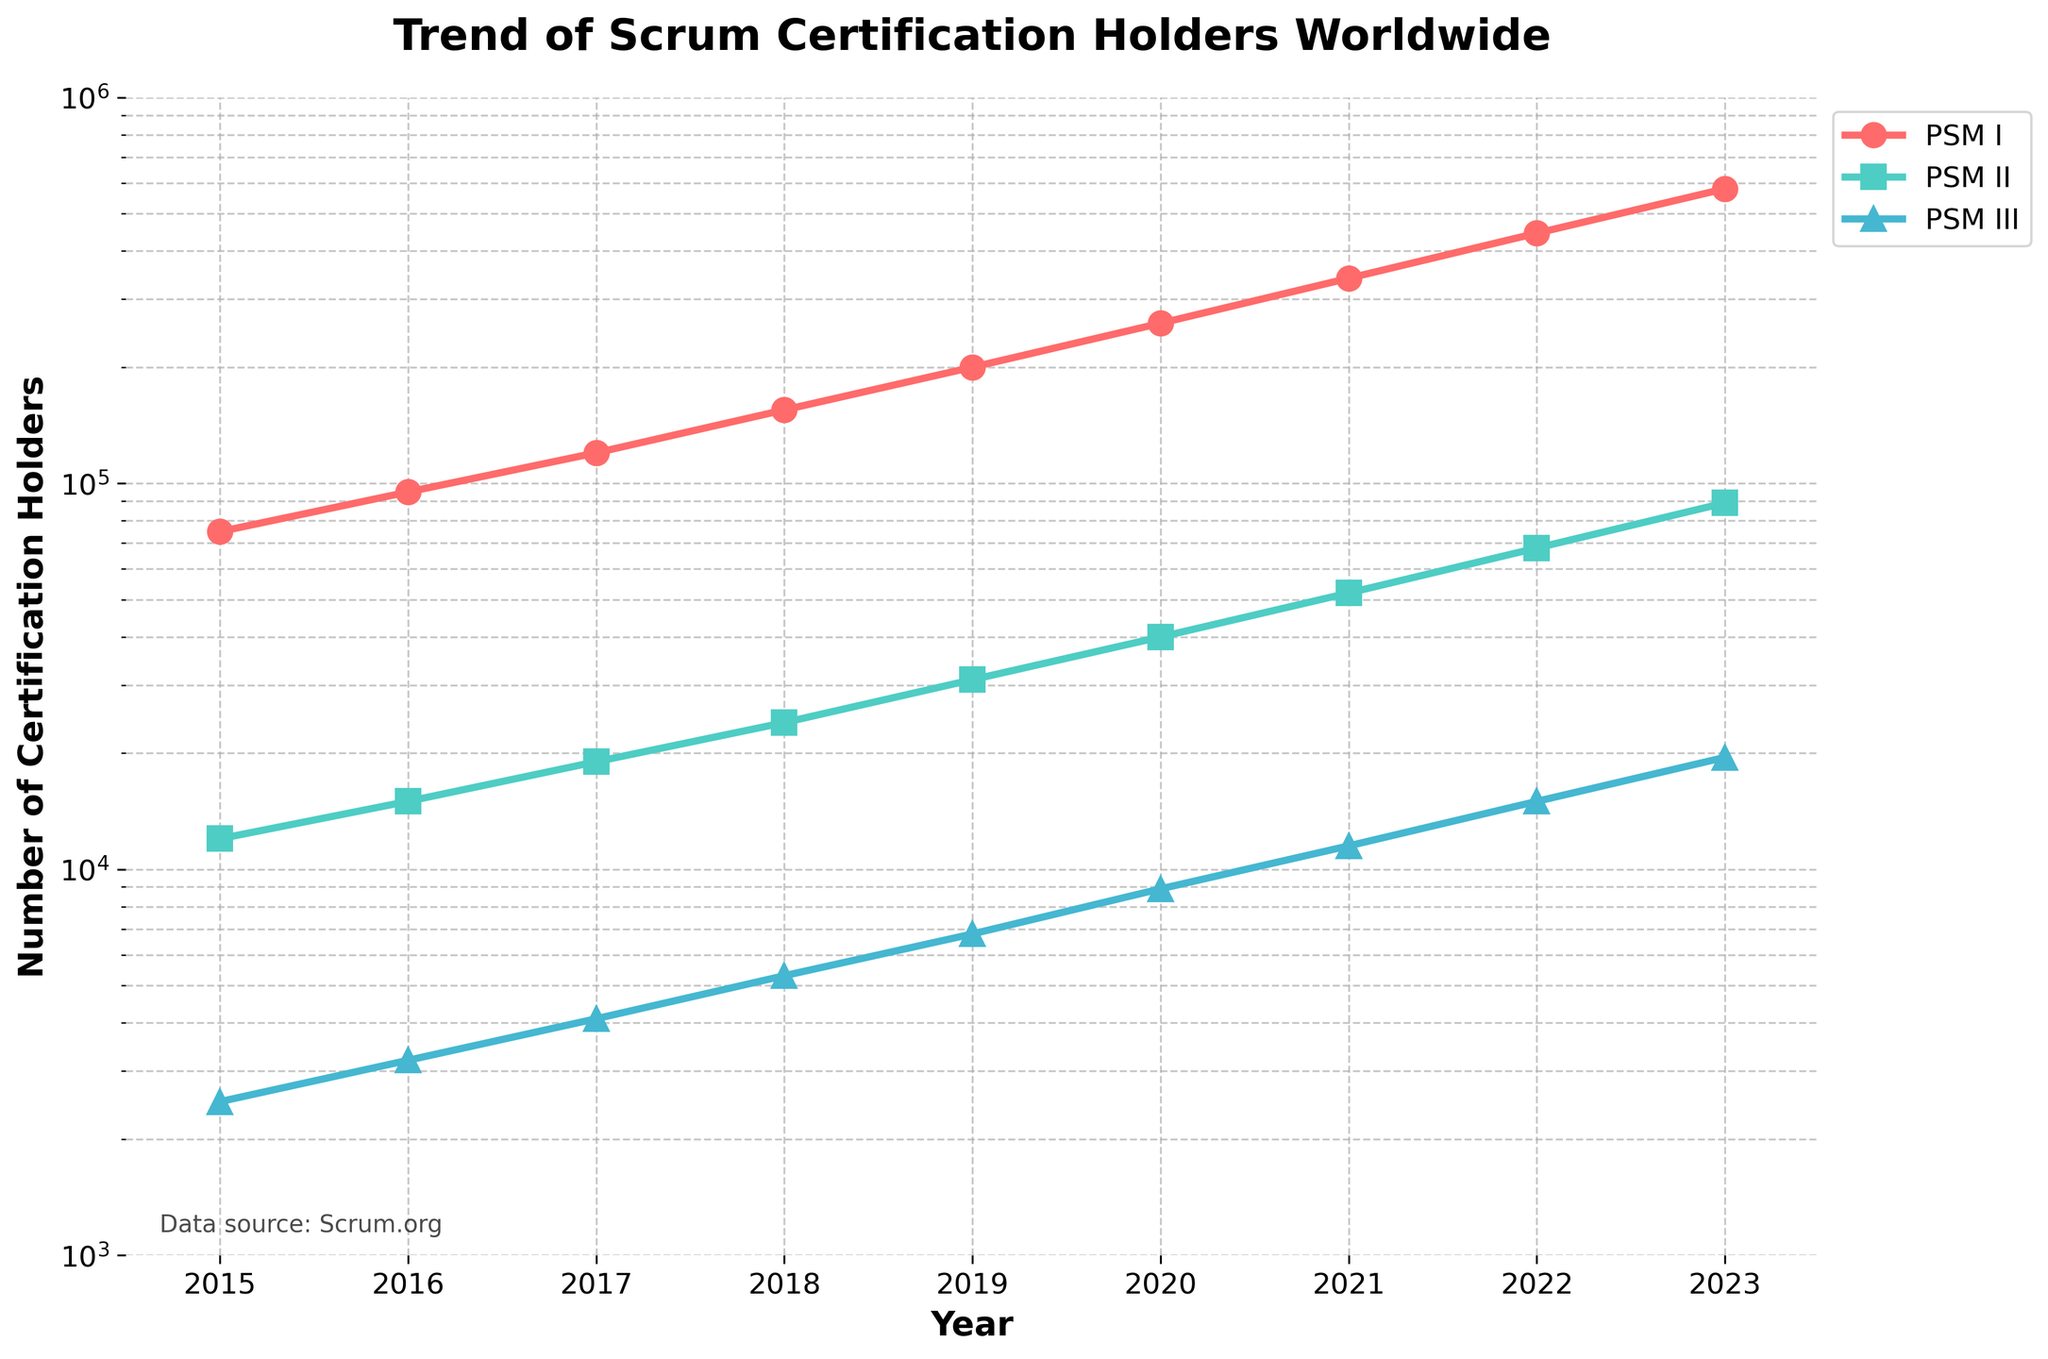What is the trend in the number of PSM I certification holders from 2015 to 2023? The number of PSM I certification holders increases significantly from 75,000 in 2015 to 580,000 in 2023. There is consistent growth each year.
Answer: Increasing Which certification level had the smallest number of holders in 2023? PSM III has the smallest number of holders in 2023, with 19,500, compared to PSM I and PSM II.
Answer: PSM III How many more PSM I certification holders are there in 2023 compared to 2015? In 2023, there are 580,000 PSM I holders, whereas in 2015, there were 75,000. Subtracting these values gives 580,000 - 75,000 = 505,000.
Answer: 505,000 Which year saw the largest increase in the number of PSM II certification holders, and what was that increase? The increase in PSM II holders is calculated yearly. The largest increase was from 2022 to 2023, going from 68,000 to 89,000, resulting in 89,000 - 68,000 = 21,000.
Answer: 2022-2023, 21,000 Compare the growth rate of PSM III certification holders between 2022 and 2023 with that between 2021 and 2022. Growth rate for 2021-2022: (15,000 - 11,500) / 11,500 ≈ 0.3043 or 30.43%. Growth rate for 2022-2023: (19,500 - 15,000) / 15,000 ≈ 0.3 or 30%. The growth rates are almost equal.
Answer: Nearly equal Around which year did the number of PSM I holders reach approximately 200,000? The number of PSM I holders first surpasses 200,000 in 2019.
Answer: 2019 What is the total number of all certification holders (PSM I, PSM II, PSM III) in 2023? Sum of all holders in 2023: 580,000 (PSM I) + 89,000 (PSM II) + 19,500 (PSM III) = 688,500.
Answer: 688,500 How does the growth in PSM I holders compare to PSM II holders from 2015 to 2023? In 2015, PSM I holders were 75,000, increasing to 580,000 in 2023 (an increase of 505,000). For PSM II, holders in 2015 were 12,000, growing to 89,000 in 2023 (an increase of 77,000). PSM I has a much larger absolute growth compared to PSM II.
Answer: PSM I grew more What is the visual difference in how the trend lines for each certification level appear in terms of color and markers? The trend lines use different colors and markers: PSM I (red, circles), PSM II (green, squares), PSM III (blue, triangles).
Answer: PSM I: red, circles; PSM II: green, squares; PSM III: blue, triangles Which certification level shows the steepest growth trend on the log scale from 2015 to 2023 and how can you tell? All levels show a steep growth trend, but the visual steepness of PSM I appears the highest due to the largest numerical increase and slope on the log scale.
Answer: PSM I 